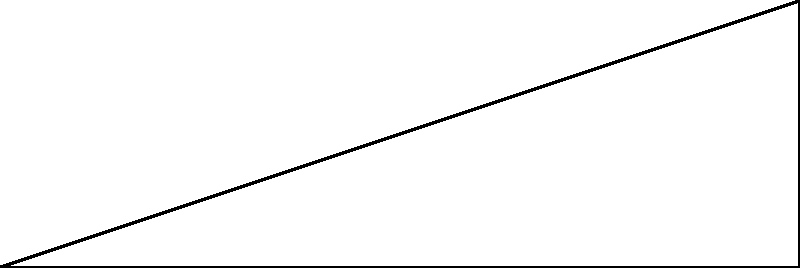You're considering buying a treadmill for low-impact exercise. The salesperson mentions that the treadmill has an adjustable incline, and shows you a diagram of its side view. If the treadmill platform is 6 cm long and can be raised 2 cm at its highest point, what is the angle of incline $\theta$ in degrees? Round your answer to the nearest whole number. To find the angle of incline, we can use basic trigonometry. Let's approach this step-by-step:

1) In the diagram, we have a right-angled triangle OAB, where:
   - OA is the length of the treadmill platform (6 cm)
   - AB is the height the platform can be raised (2 cm)
   - Angle $\theta$ at O is what we need to find

2) In a right-angled triangle, we can use the tangent function to find an angle when we know the opposite and adjacent sides:

   $\tan(\theta) = \frac{\text{opposite}}{\text{adjacent}} = \frac{AB}{OA}$

3) Substituting our known values:

   $\tan(\theta) = \frac{2}{6} = \frac{1}{3}$

4) To find $\theta$, we need to use the inverse tangent (arctan or $\tan^{-1}$) function:

   $\theta = \tan^{-1}(\frac{1}{3})$

5) Using a calculator or computer:

   $\theta \approx 18.43$ degrees

6) Rounding to the nearest whole number:

   $\theta \approx 18$ degrees

This incline angle provides a gentle slope, suitable for low-impact exercise, especially for those who need to be mindful of joint stress.
Answer: 18 degrees 